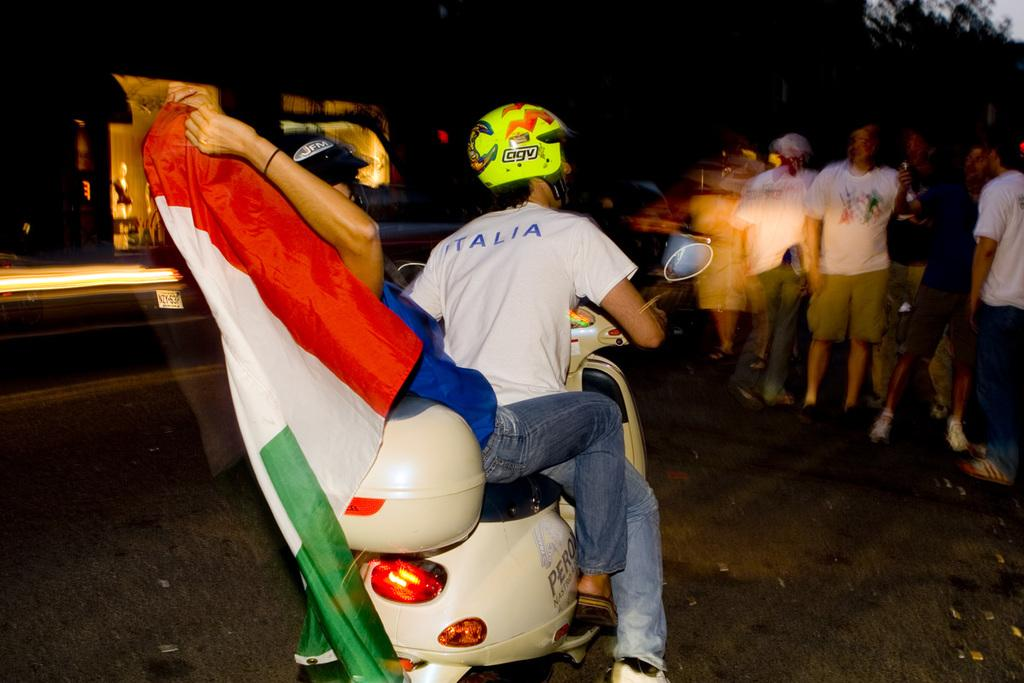How many people are in the image? There are people in the image, specifically two people riding a motorcycle. What are the people on the motorcycle doing? The two people are riding a motorcycle. What is the person holding in the image? One person is holding a flag. What is the color of the background in the image? The background of the image is dark. How many beetles can be seen crawling on the motorcycle in the image? There are no beetles visible in the image; it features people riding a motorcycle and holding a flag. What is the value of the quarter on the motorcycle in the image? There is no quarter present in the image. 